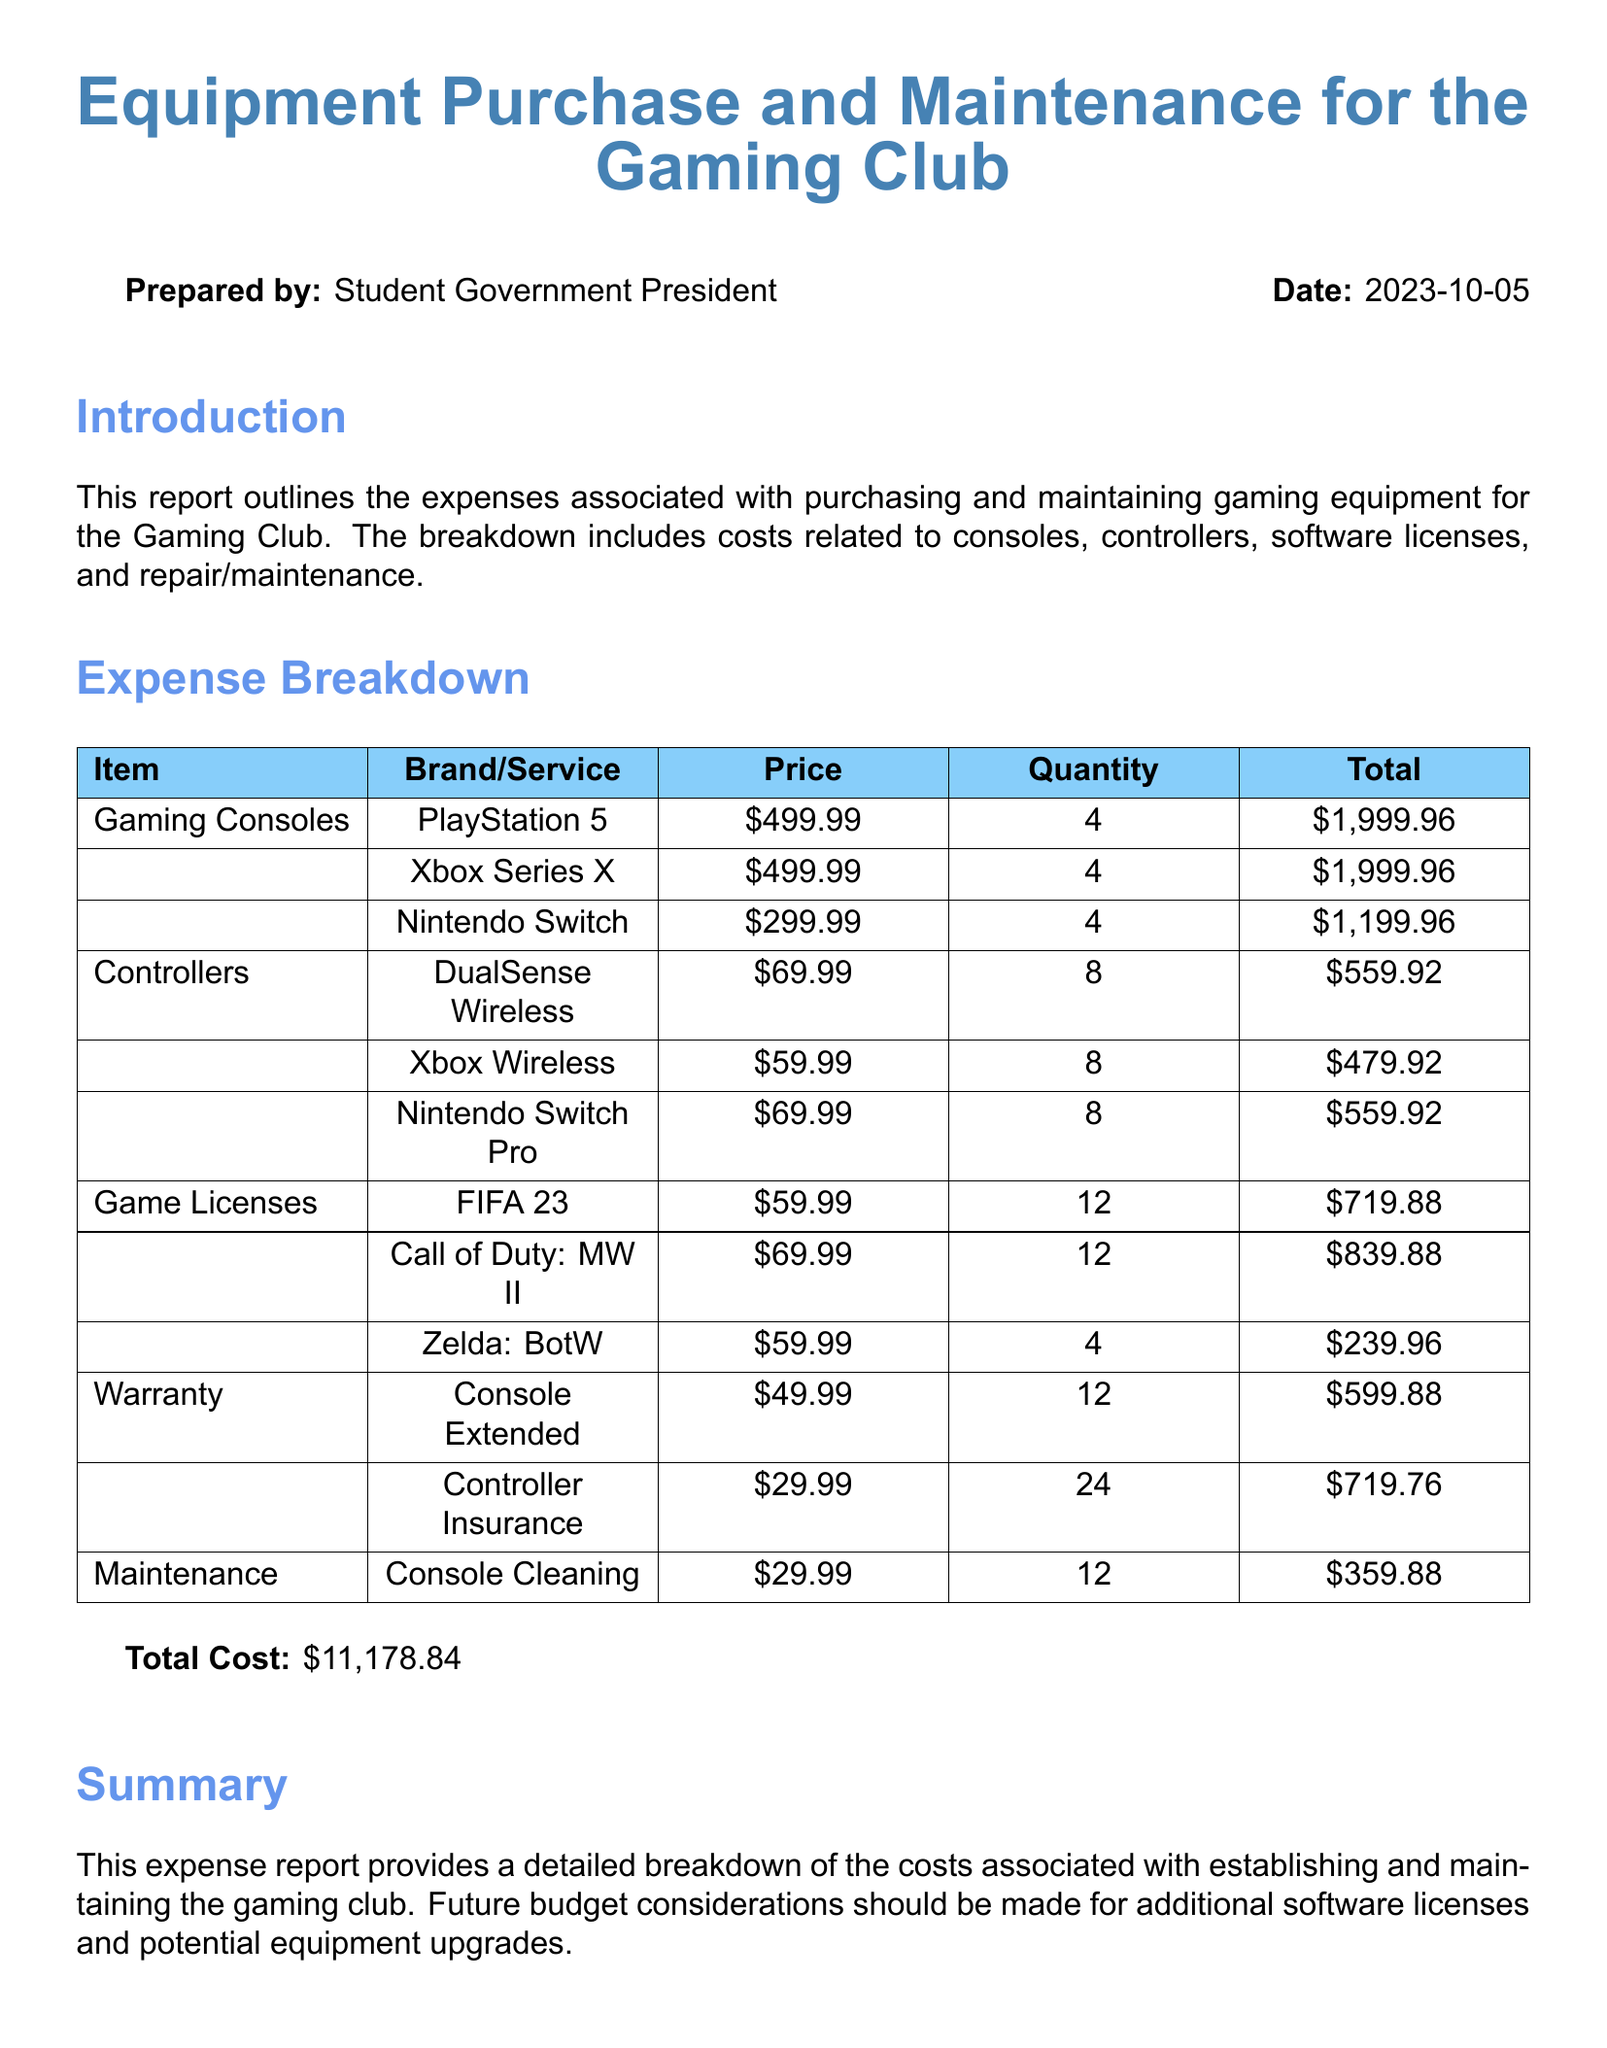What is the total cost of the expenses? The total cost is calculated based on the sum of all items listed in the expense breakdown.
Answer: $11,178.84 How many PlayStation 5 consoles were purchased? The number of PlayStation 5 consoles can be found in the itemized list under gaming consoles.
Answer: 4 What is the price of the DualSense Wireless controller? The price is specified in the expense breakdown under controllers.
Answer: $69.99 How much did the FIFA 23 game licenses cost in total? The total cost is calculated by multiplying the price per license by the quantity purchased.
Answer: $719.88 What type of warranty was purchased for the consoles? The type of warranty is specified in the expense breakdown under warranty.
Answer: Console Extended How many Controller Insurance plans were purchased? The quantity can be found in the warranty section of the expense report.
Answer: 24 What is the cost of console cleaning maintenance? The cost of maintaining the consoles through cleaning is listed in the maintenance section.
Answer: $29.99 Which gaming console had the lowest total expenditure? The total expenditures of each console are compared to identify the lowest one.
Answer: Nintendo Switch What was the total cost for the Xbox wireless controllers? The total cost can be calculated from the price and quantity given in the itemized list.
Answer: $479.92 